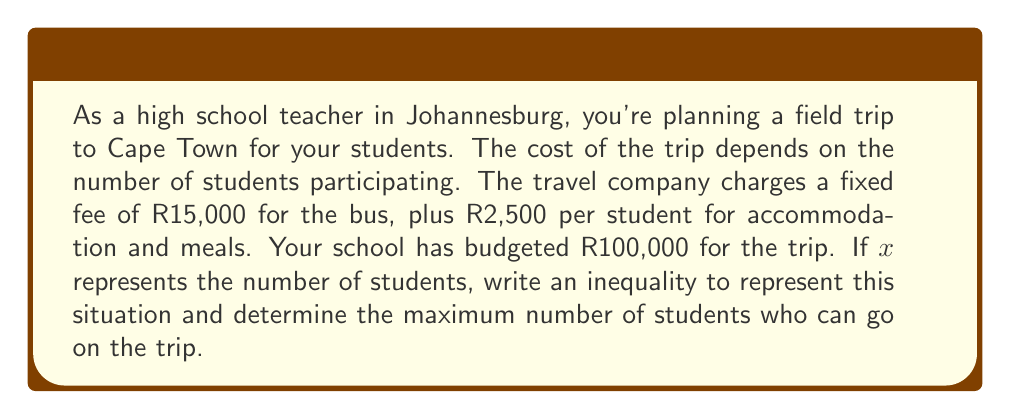Provide a solution to this math problem. Let's approach this step-by-step:

1) First, we need to set up an inequality that represents the total cost of the trip being less than or equal to the budget.

2) The total cost consists of two parts:
   - Fixed cost for the bus: R15,000
   - Per-student cost: R2,500 × $x$ (where $x$ is the number of students)

3) So, our inequality is:
   $$ 15000 + 2500x \leq 100000 $$

4) To solve this inequality, we first subtract 15000 from both sides:
   $$ 2500x \leq 85000 $$

5) Now, divide both sides by 2500:
   $$ x \leq 34 $$

6) Since $x$ represents the number of students, it must be a whole number. Therefore, the maximum number of students is the largest integer less than or equal to 34.
Answer: The inequality representing the situation is:
$$ 15000 + 2500x \leq 100000 $$
The maximum number of students who can go on the trip is 34. 